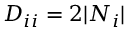<formula> <loc_0><loc_0><loc_500><loc_500>D _ { i i } = 2 | N _ { i } |</formula> 